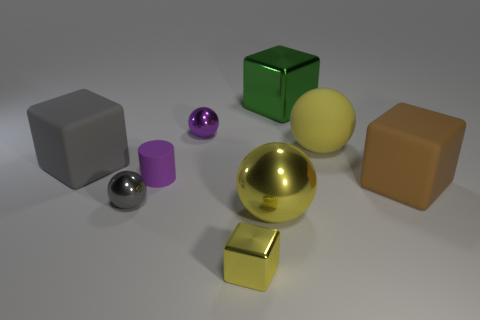Subtract 1 cubes. How many cubes are left? 3 Add 1 small green spheres. How many objects exist? 10 Subtract all gray balls. How many balls are left? 3 Subtract all gray matte cubes. How many cubes are left? 3 Subtract all blue balls. Subtract all brown cylinders. How many balls are left? 4 Subtract all blocks. How many objects are left? 5 Subtract 0 cyan cubes. How many objects are left? 9 Subtract all tiny yellow cubes. Subtract all small purple metallic spheres. How many objects are left? 7 Add 6 gray metallic spheres. How many gray metallic spheres are left? 7 Add 4 large green blocks. How many large green blocks exist? 5 